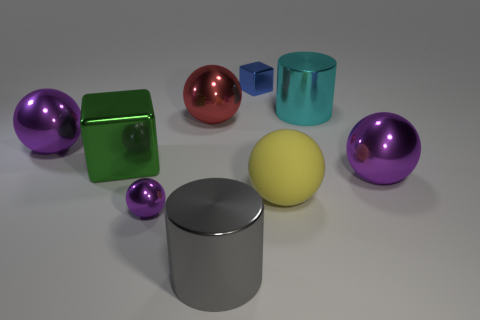Subtract all purple balls. How many were subtracted if there are1purple balls left? 2 Subtract all large spheres. How many spheres are left? 1 Subtract all yellow cylinders. How many purple spheres are left? 3 Add 1 cyan metallic objects. How many objects exist? 10 Subtract all yellow spheres. How many spheres are left? 4 Subtract 1 cubes. How many cubes are left? 1 Add 3 big purple shiny balls. How many big purple shiny balls exist? 5 Subtract 1 gray cylinders. How many objects are left? 8 Subtract all balls. How many objects are left? 4 Subtract all purple spheres. Subtract all brown cubes. How many spheres are left? 2 